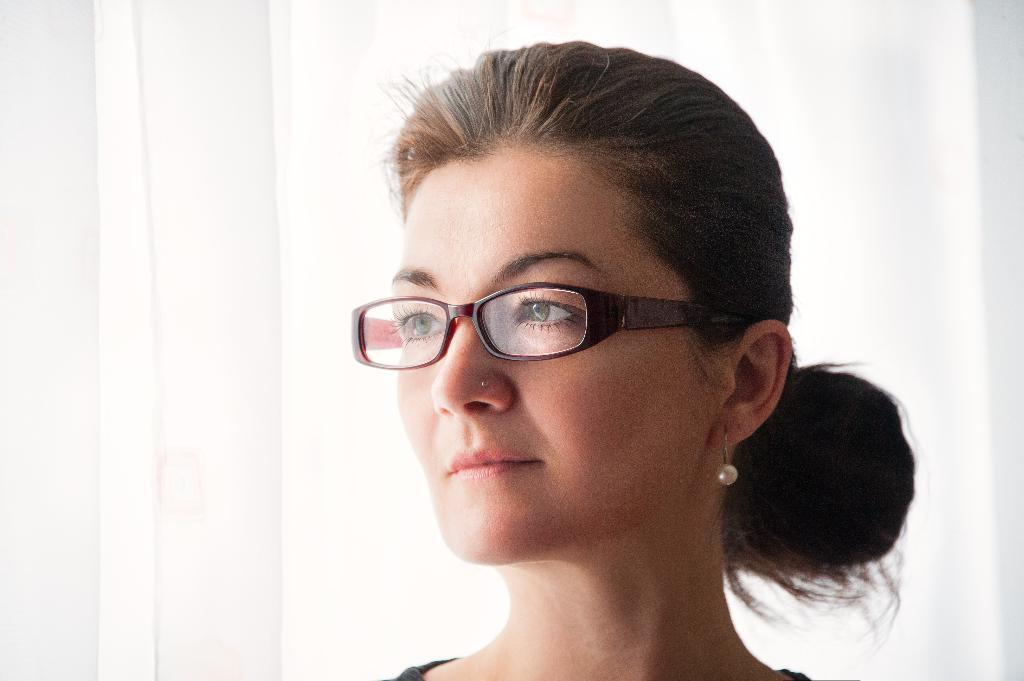What is the main subject of the image? The main subject of the image is a woman. Can you describe any accessories the woman is wearing? The woman is wearing spectacles in the image. Are there any other noticeable features about the woman? Yes, the woman has a nose pin. What type of quartz can be seen on the sidewalk near the woman in the image? There is no quartz present in the image, and the woman is not standing on a sidewalk. 